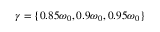Convert formula to latex. <formula><loc_0><loc_0><loc_500><loc_500>\gamma = \{ { 0 . 8 5 \omega _ { 0 } , 0 . 9 \omega _ { 0 } , 0 . 9 5 \omega _ { 0 } \} }</formula> 